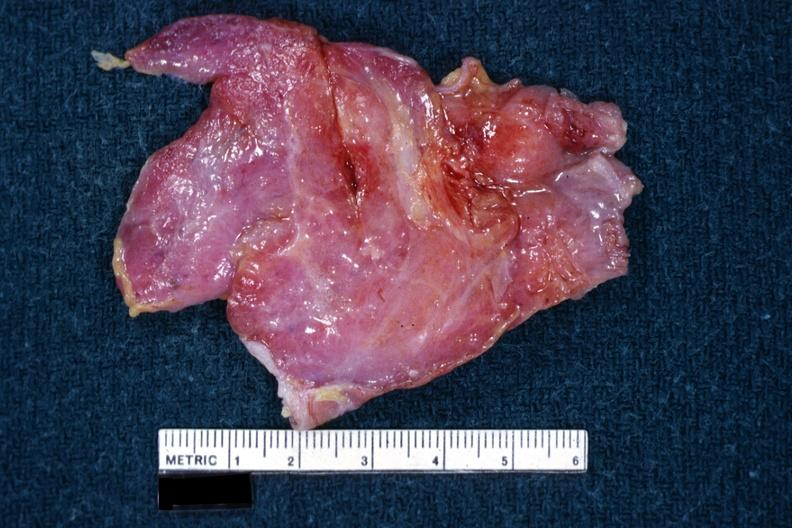what is present?
Answer the question using a single word or phrase. Thymus 